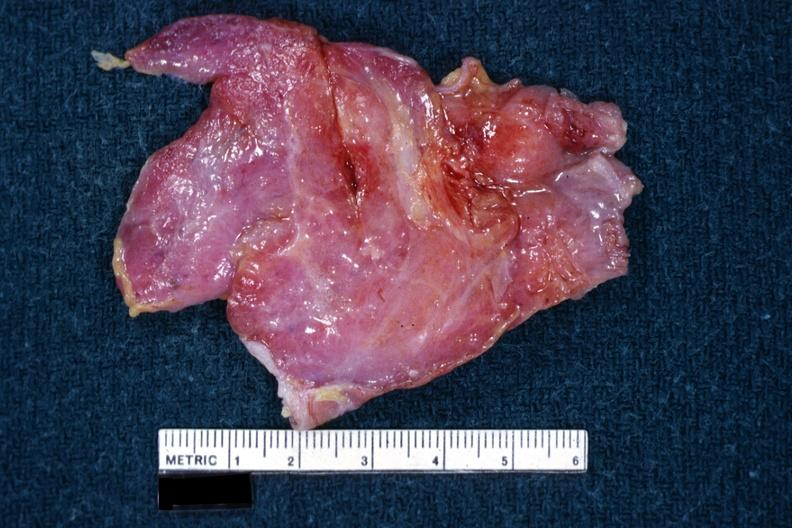what is present?
Answer the question using a single word or phrase. Thymus 